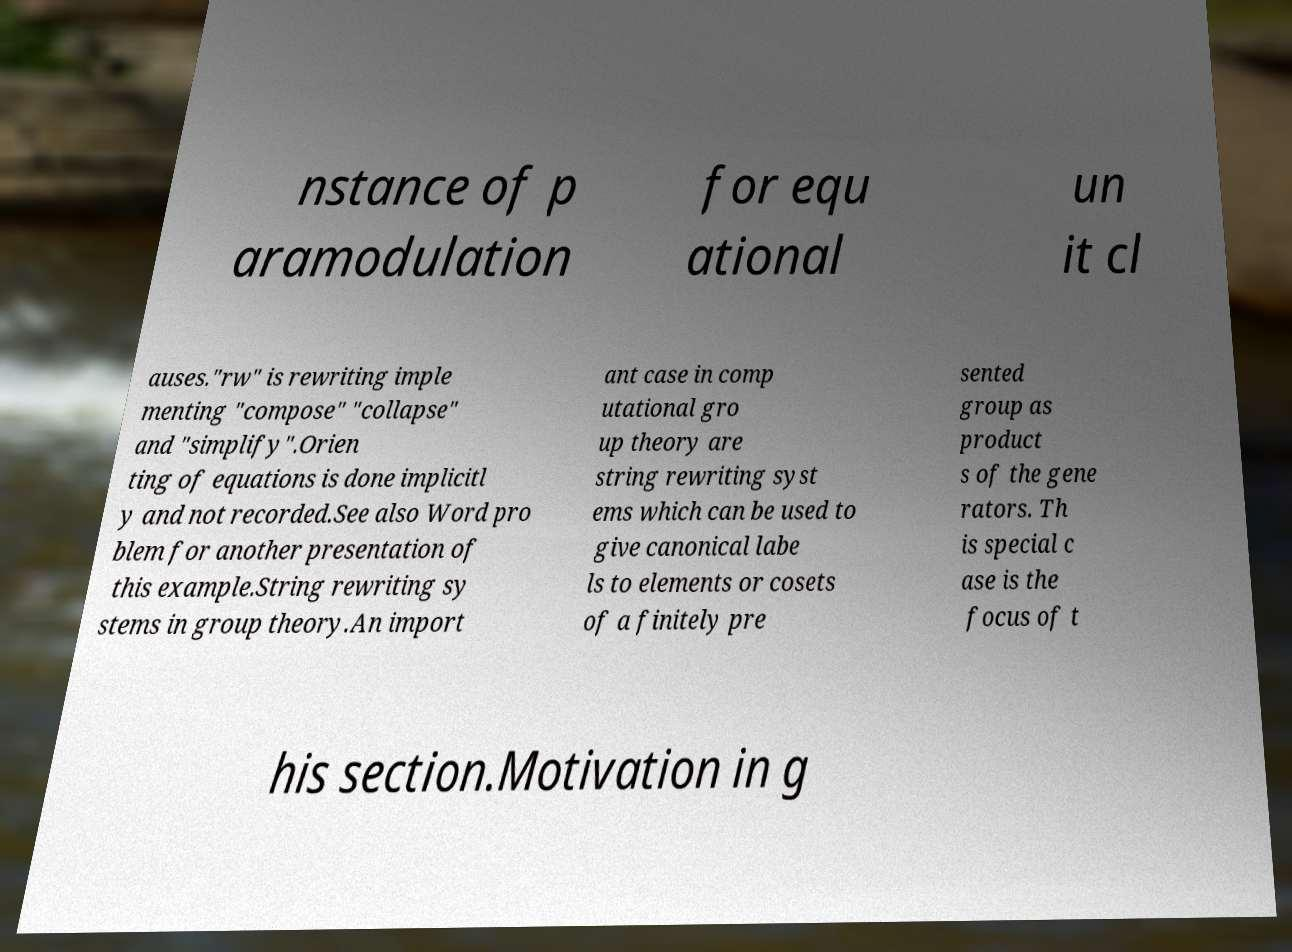Please identify and transcribe the text found in this image. nstance of p aramodulation for equ ational un it cl auses."rw" is rewriting imple menting "compose" "collapse" and "simplify".Orien ting of equations is done implicitl y and not recorded.See also Word pro blem for another presentation of this example.String rewriting sy stems in group theory.An import ant case in comp utational gro up theory are string rewriting syst ems which can be used to give canonical labe ls to elements or cosets of a finitely pre sented group as product s of the gene rators. Th is special c ase is the focus of t his section.Motivation in g 